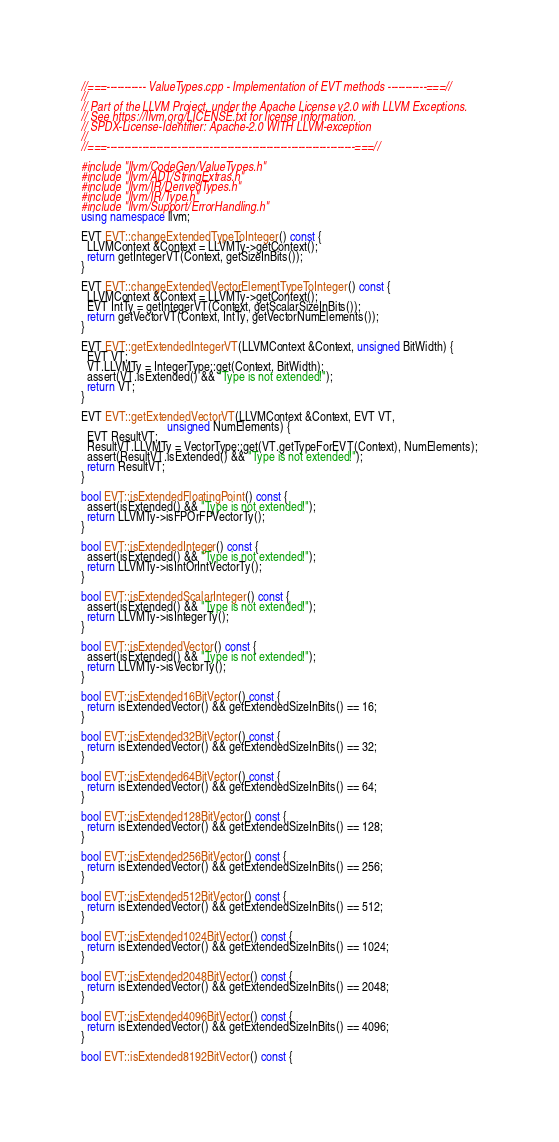Convert code to text. <code><loc_0><loc_0><loc_500><loc_500><_C++_>//===----------- ValueTypes.cpp - Implementation of EVT methods -----------===//
//
// Part of the LLVM Project, under the Apache License v2.0 with LLVM Exceptions.
// See https://llvm.org/LICENSE.txt for license information.
// SPDX-License-Identifier: Apache-2.0 WITH LLVM-exception
//
//===----------------------------------------------------------------------===//

#include "llvm/CodeGen/ValueTypes.h"
#include "llvm/ADT/StringExtras.h"
#include "llvm/IR/DerivedTypes.h"
#include "llvm/IR/Type.h"
#include "llvm/Support/ErrorHandling.h"
using namespace llvm;

EVT EVT::changeExtendedTypeToInteger() const {
  LLVMContext &Context = LLVMTy->getContext();
  return getIntegerVT(Context, getSizeInBits());
}

EVT EVT::changeExtendedVectorElementTypeToInteger() const {
  LLVMContext &Context = LLVMTy->getContext();
  EVT IntTy = getIntegerVT(Context, getScalarSizeInBits());
  return getVectorVT(Context, IntTy, getVectorNumElements());
}

EVT EVT::getExtendedIntegerVT(LLVMContext &Context, unsigned BitWidth) {
  EVT VT;
  VT.LLVMTy = IntegerType::get(Context, BitWidth);
  assert(VT.isExtended() && "Type is not extended!");
  return VT;
}

EVT EVT::getExtendedVectorVT(LLVMContext &Context, EVT VT,
                             unsigned NumElements) {
  EVT ResultVT;
  ResultVT.LLVMTy = VectorType::get(VT.getTypeForEVT(Context), NumElements);
  assert(ResultVT.isExtended() && "Type is not extended!");
  return ResultVT;
}

bool EVT::isExtendedFloatingPoint() const {
  assert(isExtended() && "Type is not extended!");
  return LLVMTy->isFPOrFPVectorTy();
}

bool EVT::isExtendedInteger() const {
  assert(isExtended() && "Type is not extended!");
  return LLVMTy->isIntOrIntVectorTy();
}

bool EVT::isExtendedScalarInteger() const {
  assert(isExtended() && "Type is not extended!");
  return LLVMTy->isIntegerTy();
}

bool EVT::isExtendedVector() const {
  assert(isExtended() && "Type is not extended!");
  return LLVMTy->isVectorTy();
}

bool EVT::isExtended16BitVector() const {
  return isExtendedVector() && getExtendedSizeInBits() == 16;
}

bool EVT::isExtended32BitVector() const {
  return isExtendedVector() && getExtendedSizeInBits() == 32;
}

bool EVT::isExtended64BitVector() const {
  return isExtendedVector() && getExtendedSizeInBits() == 64;
}

bool EVT::isExtended128BitVector() const {
  return isExtendedVector() && getExtendedSizeInBits() == 128;
}

bool EVT::isExtended256BitVector() const {
  return isExtendedVector() && getExtendedSizeInBits() == 256;
}

bool EVT::isExtended512BitVector() const {
  return isExtendedVector() && getExtendedSizeInBits() == 512;
}

bool EVT::isExtended1024BitVector() const {
  return isExtendedVector() && getExtendedSizeInBits() == 1024;
}

bool EVT::isExtended2048BitVector() const {
  return isExtendedVector() && getExtendedSizeInBits() == 2048;
}

bool EVT::isExtended4096BitVector() const {
  return isExtendedVector() && getExtendedSizeInBits() == 4096;
}

bool EVT::isExtended8192BitVector() const {</code> 